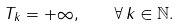Convert formula to latex. <formula><loc_0><loc_0><loc_500><loc_500>T _ { k } = + \infty , \quad \forall \, k \in \mathbb { N } .</formula> 